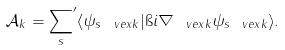Convert formula to latex. <formula><loc_0><loc_0><loc_500><loc_500>\mathcal { A } _ { k } = { \sum _ { s } } ^ { \prime } \langle \psi _ { s \ v e x k } | \i i \nabla _ { \ v e x k } \psi _ { s \ v e x k } \rangle .</formula> 